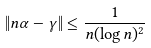<formula> <loc_0><loc_0><loc_500><loc_500>\| n \alpha - \gamma \| \leq \frac { 1 } { n ( \log n ) ^ { 2 } }</formula> 